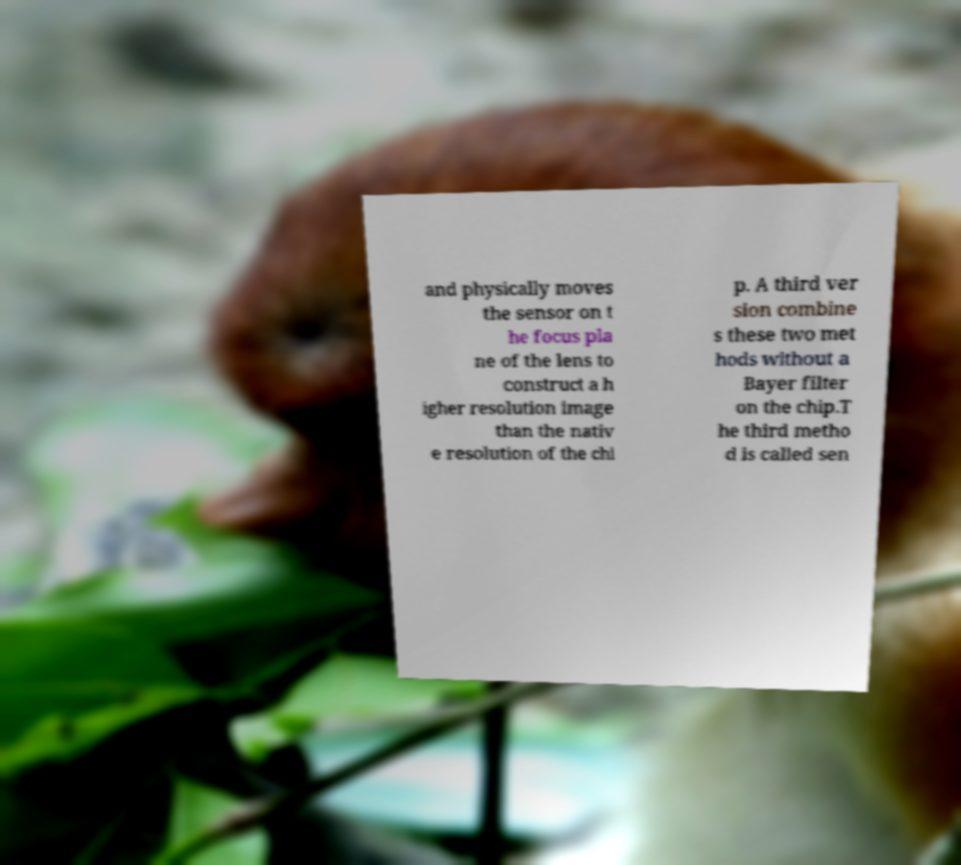Please read and relay the text visible in this image. What does it say? and physically moves the sensor on t he focus pla ne of the lens to construct a h igher resolution image than the nativ e resolution of the chi p. A third ver sion combine s these two met hods without a Bayer filter on the chip.T he third metho d is called sen 